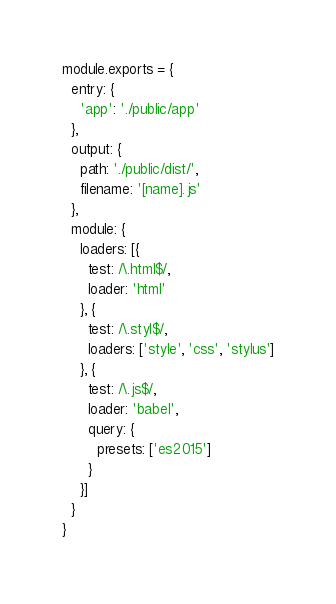<code> <loc_0><loc_0><loc_500><loc_500><_JavaScript_>module.exports = {
  entry: {
    'app': './public/app'
  },
  output: {
    path: './public/dist/',
    filename: '[name].js'
  },
  module: {
    loaders: [{
      test: /\.html$/,
      loader: 'html'
    }, {
      test: /\.styl$/,
      loaders: ['style', 'css', 'stylus']
    }, {
      test: /\.js$/,
      loader: 'babel',
      query: {
        presets: ['es2015']
      }
    }]
  }
}
</code> 